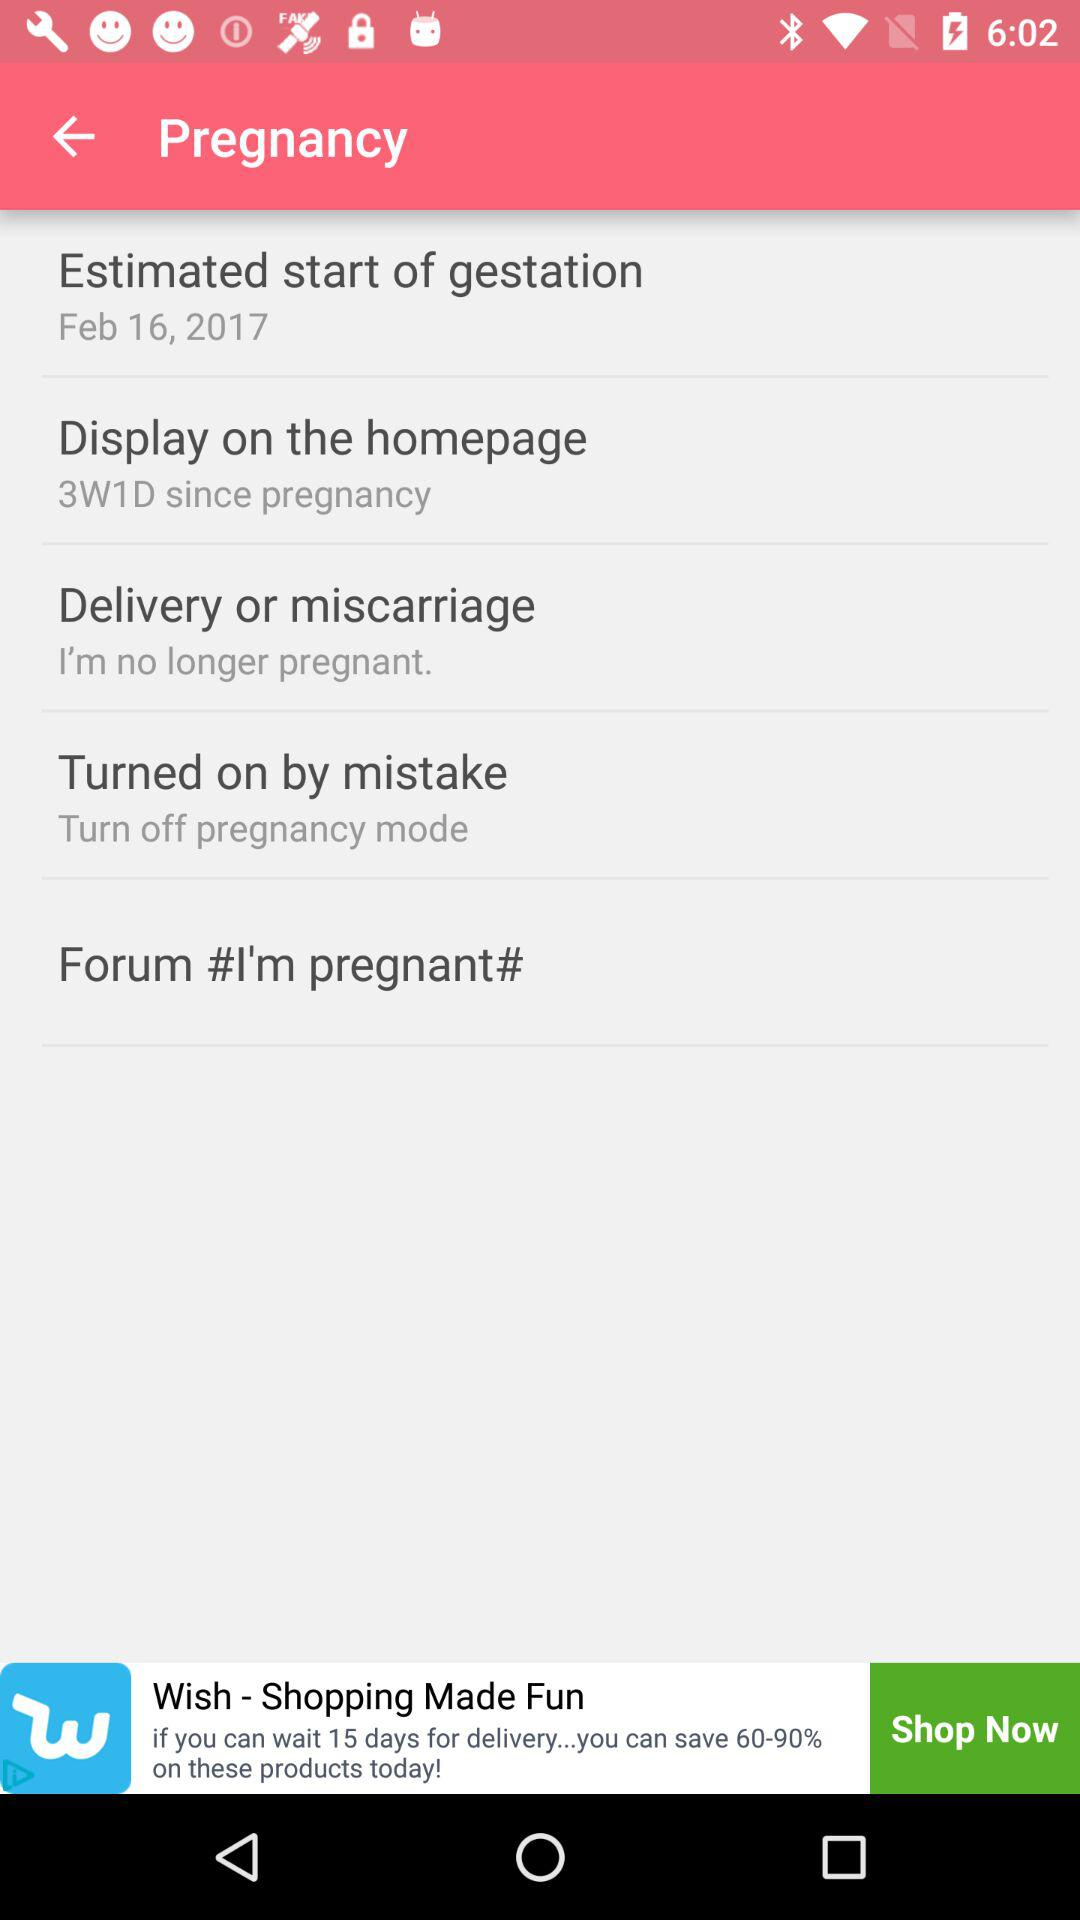What is the duration of pregnancy?
When the provided information is insufficient, respond with <no answer>. <no answer> 